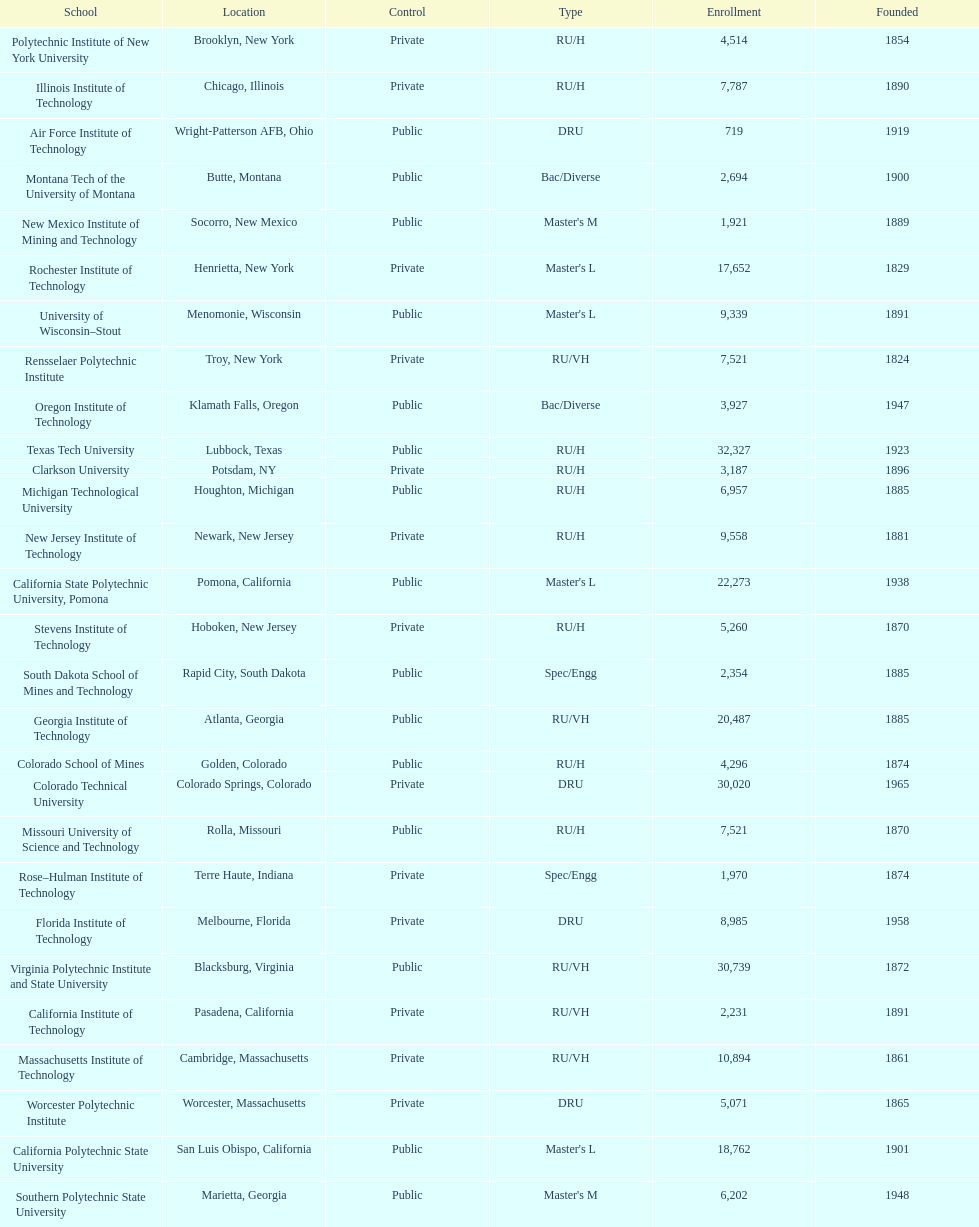What is the total number of schools listed in the table? 28. 